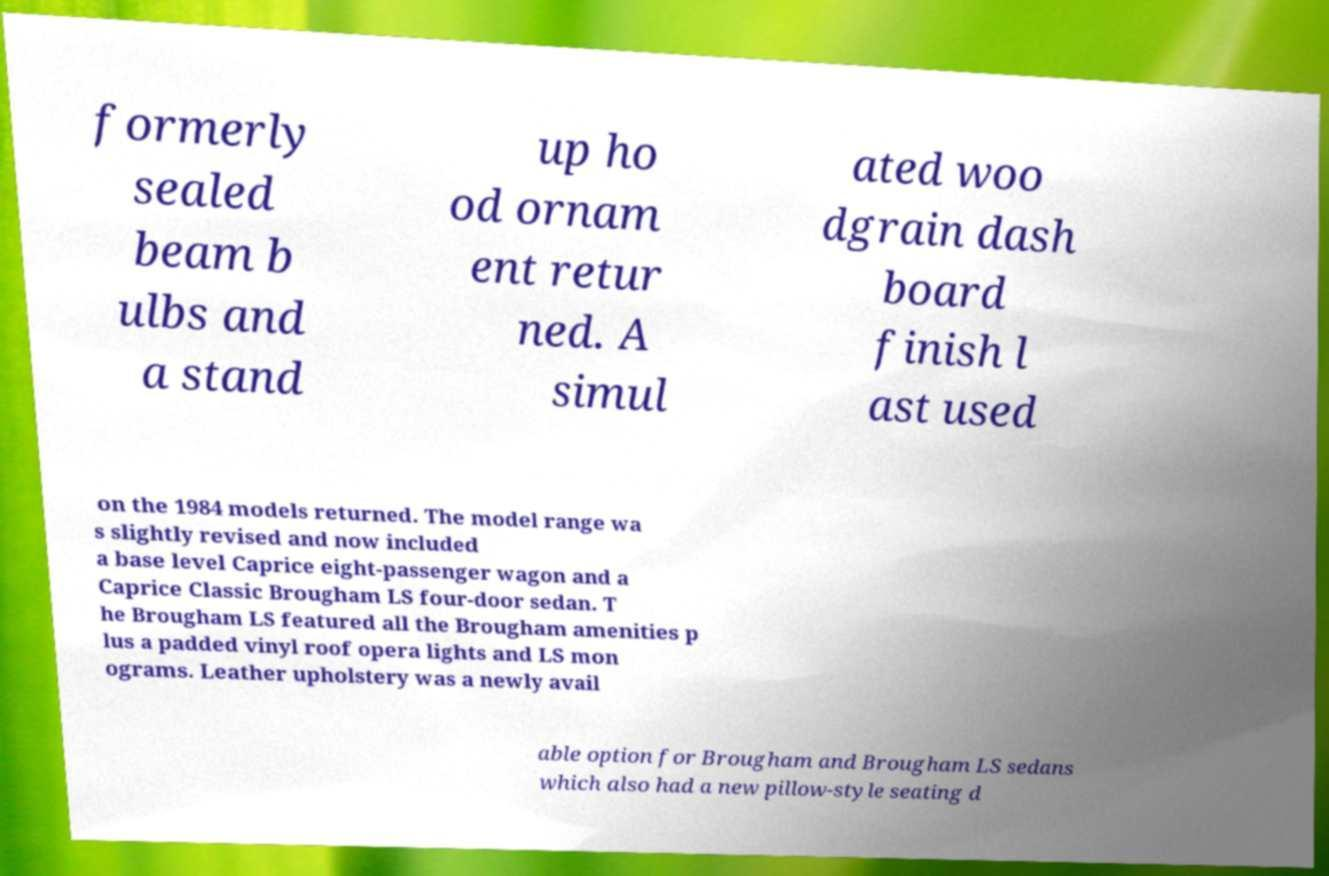Could you assist in decoding the text presented in this image and type it out clearly? formerly sealed beam b ulbs and a stand up ho od ornam ent retur ned. A simul ated woo dgrain dash board finish l ast used on the 1984 models returned. The model range wa s slightly revised and now included a base level Caprice eight-passenger wagon and a Caprice Classic Brougham LS four-door sedan. T he Brougham LS featured all the Brougham amenities p lus a padded vinyl roof opera lights and LS mon ograms. Leather upholstery was a newly avail able option for Brougham and Brougham LS sedans which also had a new pillow-style seating d 